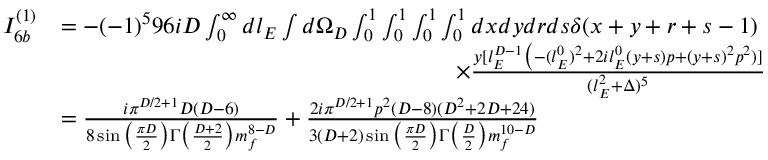<formula> <loc_0><loc_0><loc_500><loc_500>\begin{array} { r l } { I _ { 6 b } ^ { ( 1 ) } } & { = - ( - 1 ) ^ { 5 } 9 6 i D \int _ { 0 } ^ { \infty } d l _ { E } \int d \Omega _ { D } \int _ { 0 } ^ { 1 } \int _ { 0 } ^ { 1 } \int _ { 0 } ^ { 1 } \int _ { 0 } ^ { 1 } d x d y d r d s \delta ( x + y + r + s - 1 ) } \\ & { \quad \times \frac { y [ l _ { E } ^ { D - 1 } \Big ( - ( l _ { E } ^ { 0 } ) ^ { 2 } + 2 i l _ { E } ^ { 0 } ( y + s ) p + ( y + s ) ^ { 2 } p ^ { 2 } ) ] } { ( l _ { E } ^ { 2 } + \Delta ) ^ { 5 } } } \\ & { = \frac { i \pi ^ { D / 2 + 1 } D ( D - 6 ) } { 8 \sin \Big ( \frac { \pi D } { 2 } \Big ) \Gamma \Big ( \frac { D + 2 } { 2 } \Big ) m _ { f } ^ { 8 - D } } + \frac { 2 i \pi ^ { D / 2 + 1 } p ^ { 2 } ( D - 8 ) ( D ^ { 2 } + 2 D + 2 4 ) } { 3 ( D + 2 ) \sin \Big ( \frac { \pi D } { 2 } \Big ) \Gamma \Big ( \frac { D } { 2 } \Big ) m _ { f } ^ { 1 0 - D } } } \end{array}</formula> 